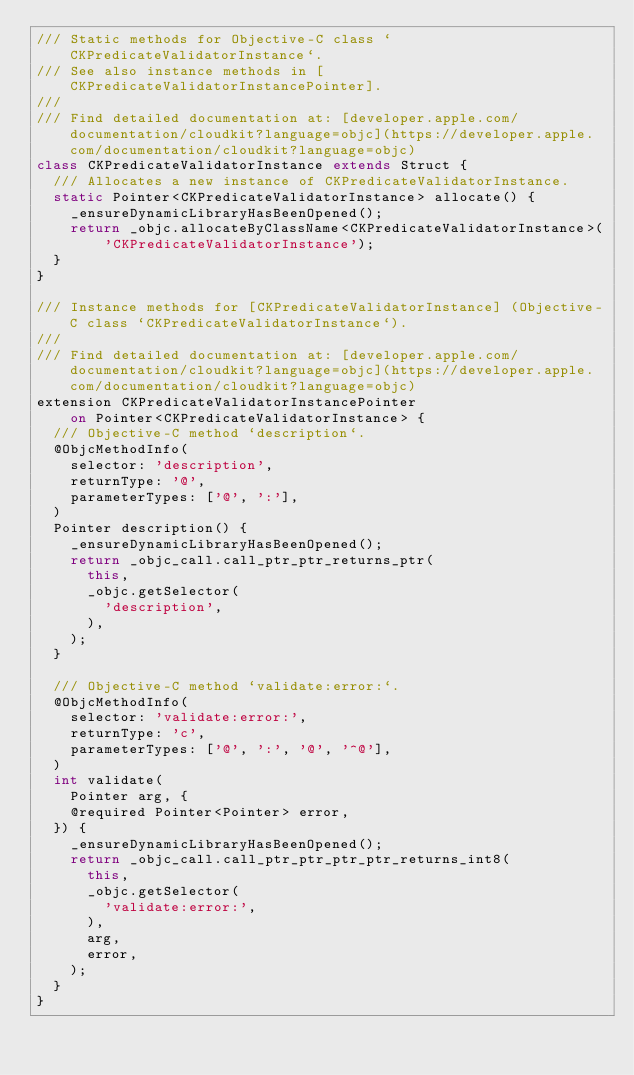<code> <loc_0><loc_0><loc_500><loc_500><_Dart_>/// Static methods for Objective-C class `CKPredicateValidatorInstance`.
/// See also instance methods in [CKPredicateValidatorInstancePointer].
///
/// Find detailed documentation at: [developer.apple.com/documentation/cloudkit?language=objc](https://developer.apple.com/documentation/cloudkit?language=objc)
class CKPredicateValidatorInstance extends Struct {
  /// Allocates a new instance of CKPredicateValidatorInstance.
  static Pointer<CKPredicateValidatorInstance> allocate() {
    _ensureDynamicLibraryHasBeenOpened();
    return _objc.allocateByClassName<CKPredicateValidatorInstance>(
        'CKPredicateValidatorInstance');
  }
}

/// Instance methods for [CKPredicateValidatorInstance] (Objective-C class `CKPredicateValidatorInstance`).
///
/// Find detailed documentation at: [developer.apple.com/documentation/cloudkit?language=objc](https://developer.apple.com/documentation/cloudkit?language=objc)
extension CKPredicateValidatorInstancePointer
    on Pointer<CKPredicateValidatorInstance> {
  /// Objective-C method `description`.
  @ObjcMethodInfo(
    selector: 'description',
    returnType: '@',
    parameterTypes: ['@', ':'],
  )
  Pointer description() {
    _ensureDynamicLibraryHasBeenOpened();
    return _objc_call.call_ptr_ptr_returns_ptr(
      this,
      _objc.getSelector(
        'description',
      ),
    );
  }

  /// Objective-C method `validate:error:`.
  @ObjcMethodInfo(
    selector: 'validate:error:',
    returnType: 'c',
    parameterTypes: ['@', ':', '@', '^@'],
  )
  int validate(
    Pointer arg, {
    @required Pointer<Pointer> error,
  }) {
    _ensureDynamicLibraryHasBeenOpened();
    return _objc_call.call_ptr_ptr_ptr_ptr_returns_int8(
      this,
      _objc.getSelector(
        'validate:error:',
      ),
      arg,
      error,
    );
  }
}
</code> 